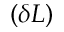Convert formula to latex. <formula><loc_0><loc_0><loc_500><loc_500>( \delta L )</formula> 